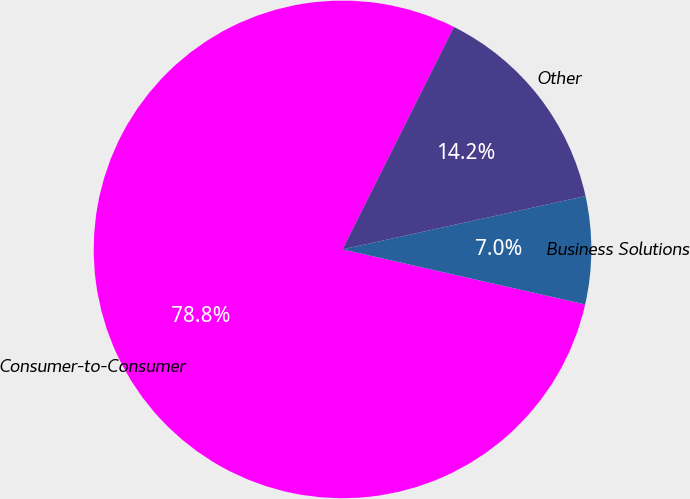Convert chart. <chart><loc_0><loc_0><loc_500><loc_500><pie_chart><fcel>Consumer-to-Consumer<fcel>Business Solutions<fcel>Other<nl><fcel>78.84%<fcel>6.99%<fcel>14.17%<nl></chart> 